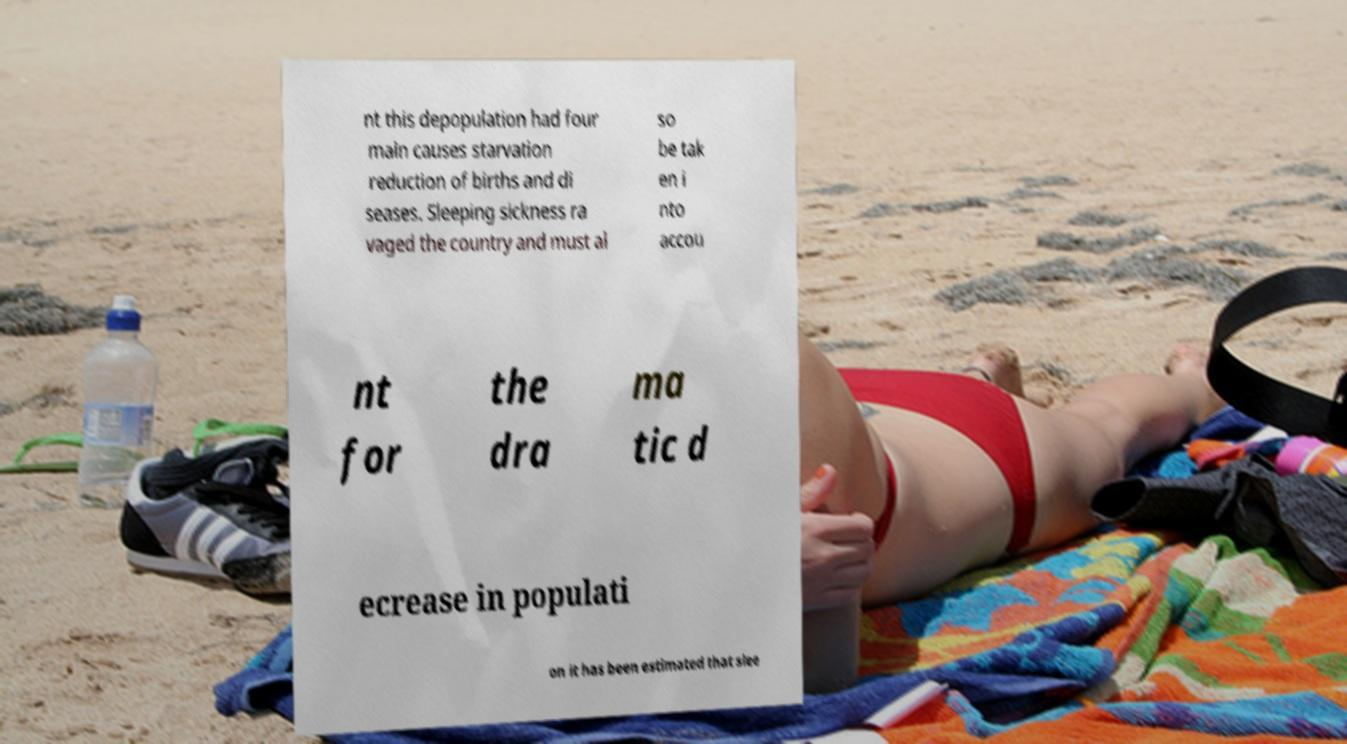There's text embedded in this image that I need extracted. Can you transcribe it verbatim? nt this depopulation had four main causes starvation reduction of births and di seases. Sleeping sickness ra vaged the country and must al so be tak en i nto accou nt for the dra ma tic d ecrease in populati on it has been estimated that slee 